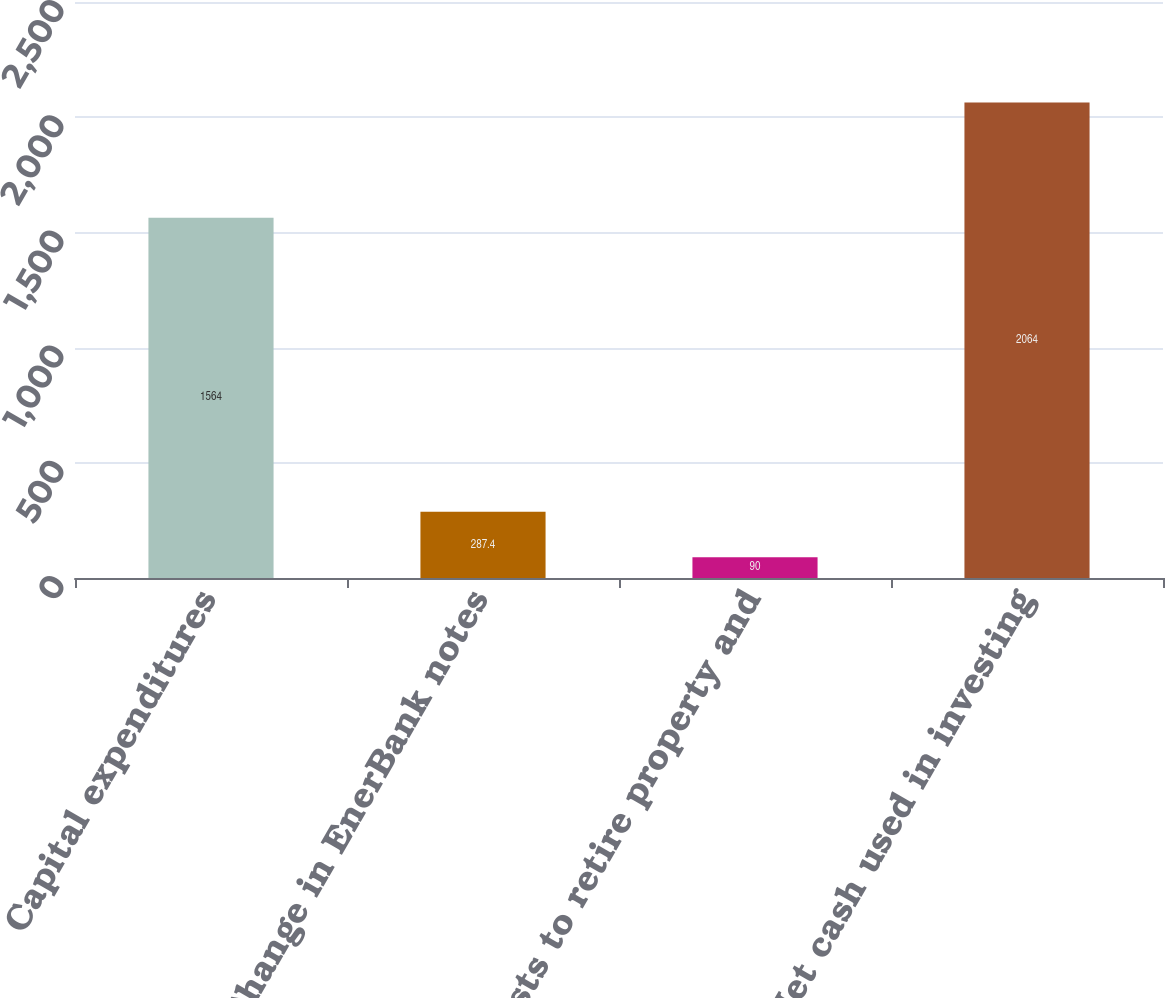Convert chart. <chart><loc_0><loc_0><loc_500><loc_500><bar_chart><fcel>Capital expenditures<fcel>Change in EnerBank notes<fcel>Costs to retire property and<fcel>Net cash used in investing<nl><fcel>1564<fcel>287.4<fcel>90<fcel>2064<nl></chart> 